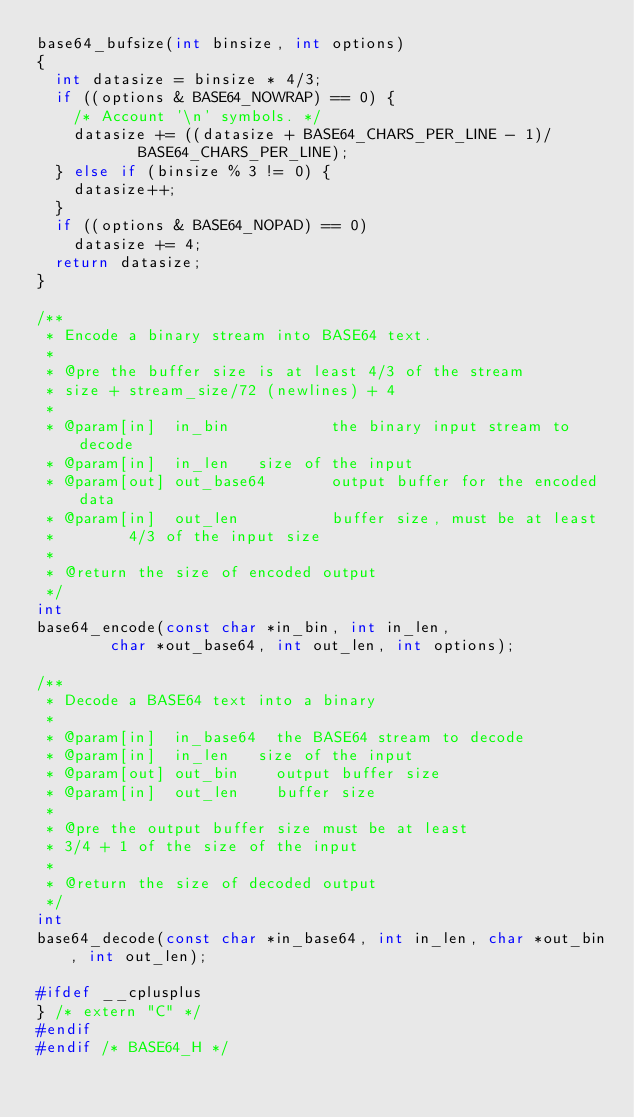<code> <loc_0><loc_0><loc_500><loc_500><_C_>base64_bufsize(int binsize, int options)
{
	int datasize = binsize * 4/3;
	if ((options & BASE64_NOWRAP) == 0) {
		/* Account '\n' symbols. */
		datasize += ((datasize + BASE64_CHARS_PER_LINE - 1)/
			     BASE64_CHARS_PER_LINE);
	} else if (binsize % 3 != 0) {
		datasize++;
	}
	if ((options & BASE64_NOPAD) == 0)
		datasize += 4;
	return datasize;
}

/**
 * Encode a binary stream into BASE64 text.
 *
 * @pre the buffer size is at least 4/3 of the stream
 * size + stream_size/72 (newlines) + 4
 *
 * @param[in]  in_bin           the binary input stream to decode
 * @param[in]  in_len		size of the input
 * @param[out] out_base64       output buffer for the encoded data
 * @param[in]  out_len          buffer size, must be at least
 *				4/3 of the input size
 *
 * @return the size of encoded output
 */
int
base64_encode(const char *in_bin, int in_len,
	      char *out_base64, int out_len, int options);

/**
 * Decode a BASE64 text into a binary
 *
 * @param[in]  in_base64	the BASE64 stream to decode
 * @param[in]  in_len		size of the input
 * @param[out] out_bin		output buffer size
 * @param[in]  out_len		buffer size
 *
 * @pre the output buffer size must be at least
 * 3/4 + 1 of the size of the input
 *
 * @return the size of decoded output
 */
int
base64_decode(const char *in_base64, int in_len, char *out_bin, int out_len);

#ifdef __cplusplus
} /* extern "C" */
#endif
#endif /* BASE64_H */

</code> 